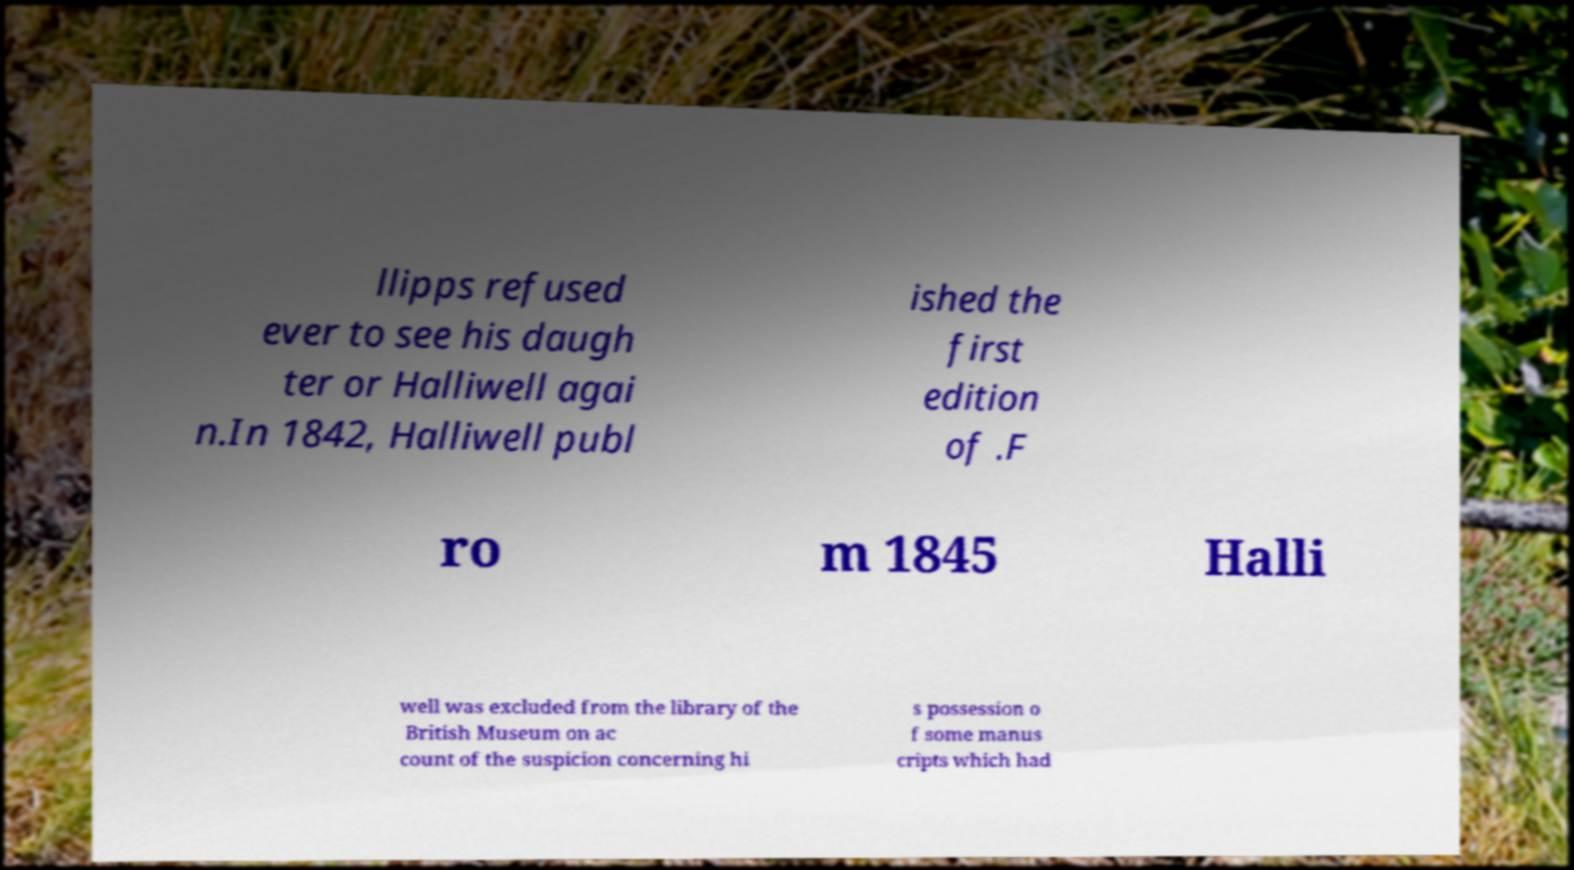Could you assist in decoding the text presented in this image and type it out clearly? llipps refused ever to see his daugh ter or Halliwell agai n.In 1842, Halliwell publ ished the first edition of .F ro m 1845 Halli well was excluded from the library of the British Museum on ac count of the suspicion concerning hi s possession o f some manus cripts which had 